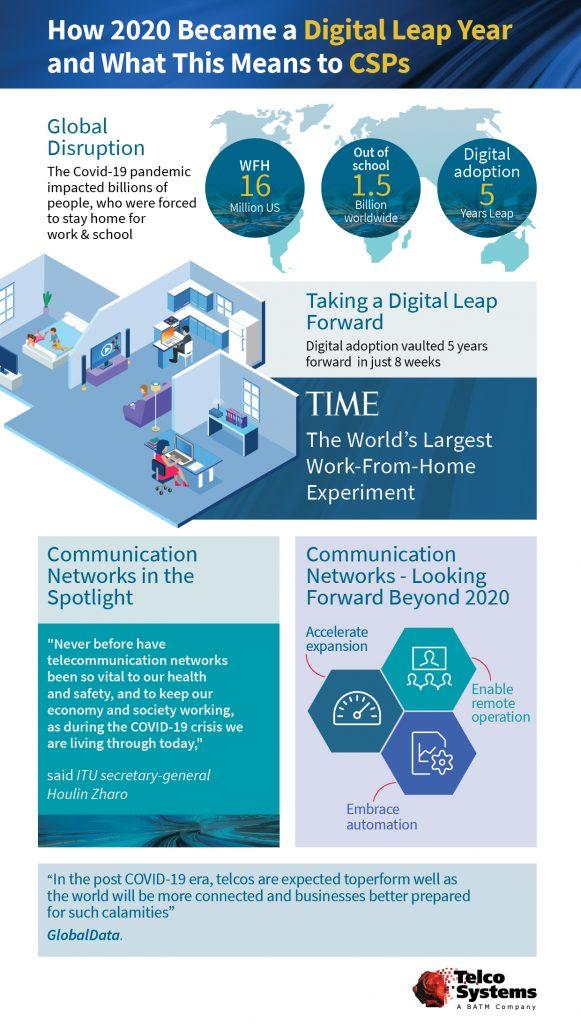Highlight a few significant elements in this photo. It is estimated that approximately 1.5 billion children are learning from home due to the COVID-19 outbreak. Communication technologies are expected to feature enhanced capabilities that include rapid expansion, remote operation, and automation, which will provide improved efficiency and ease of use. 